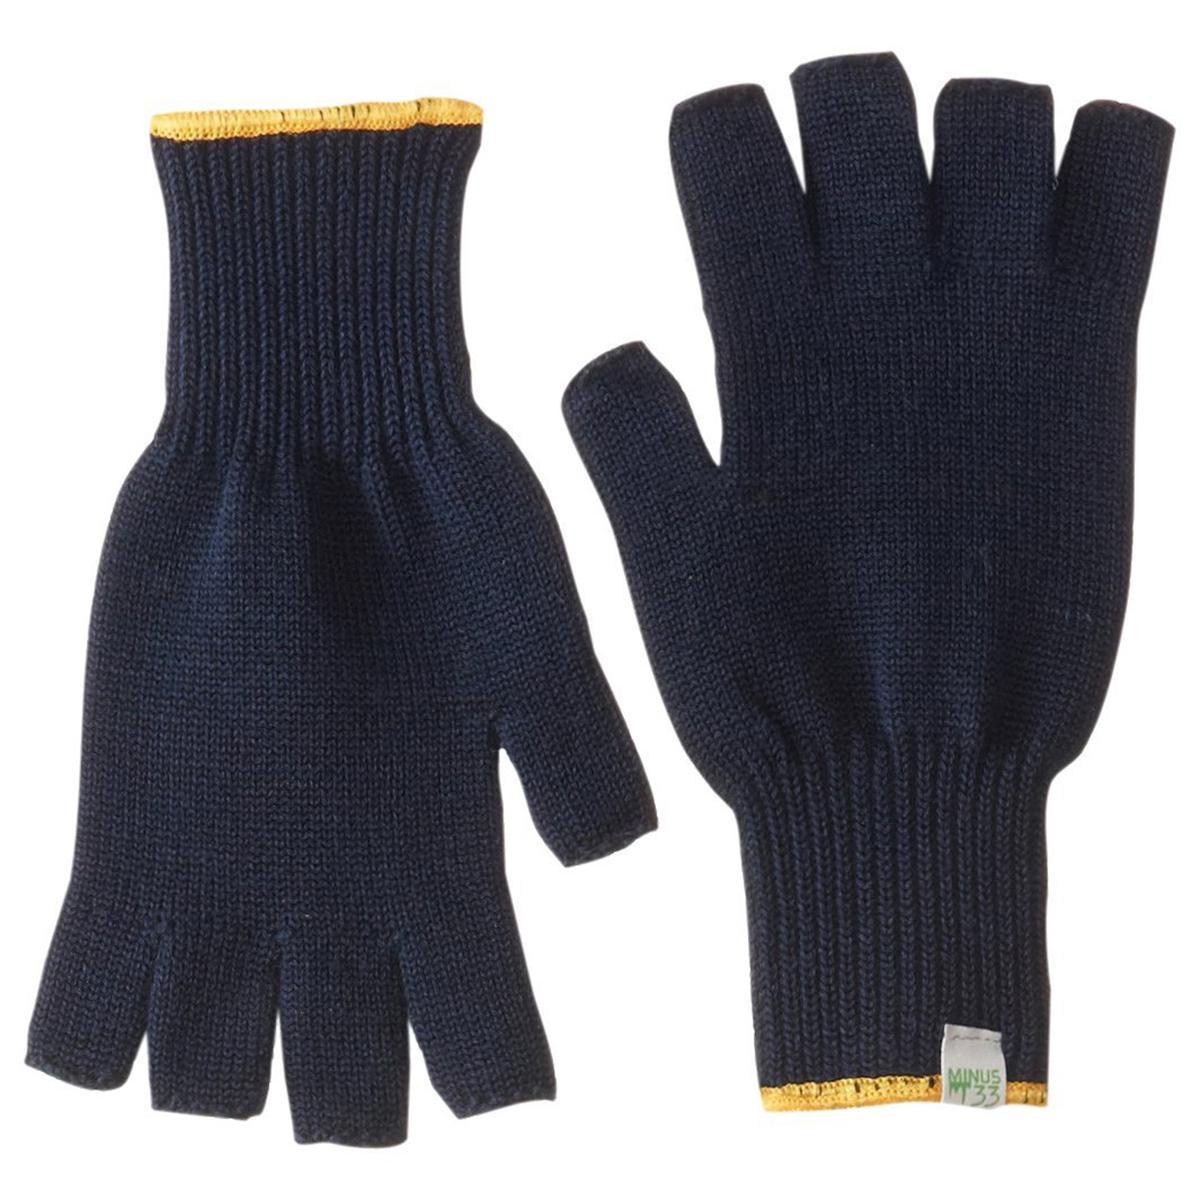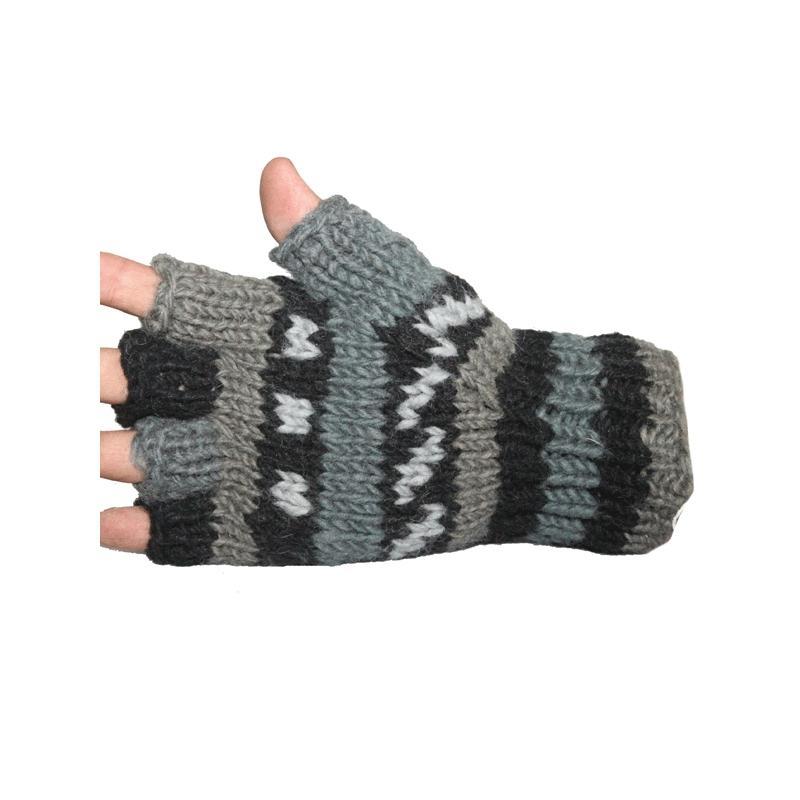The first image is the image on the left, the second image is the image on the right. For the images displayed, is the sentence "A glove is on a single hand in the image on the left." factually correct? Answer yes or no. No. The first image is the image on the left, the second image is the image on the right. Given the left and right images, does the statement "One image shows a pair of dark half-finger gloves, and the other image shows a single knitted half-finger glove with a striped pattern." hold true? Answer yes or no. Yes. 